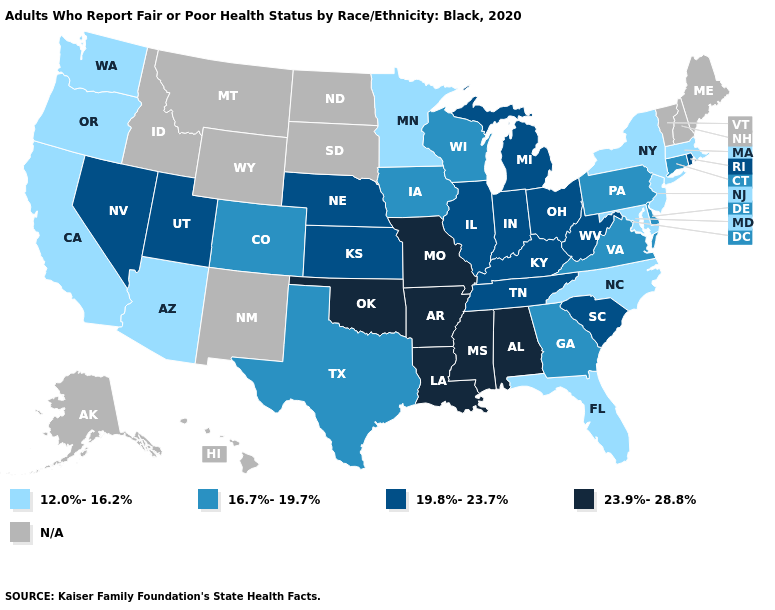Name the states that have a value in the range N/A?
Be succinct. Alaska, Hawaii, Idaho, Maine, Montana, New Hampshire, New Mexico, North Dakota, South Dakota, Vermont, Wyoming. What is the value of Texas?
Concise answer only. 16.7%-19.7%. Does Ohio have the highest value in the USA?
Give a very brief answer. No. Does Minnesota have the lowest value in the USA?
Quick response, please. Yes. Does Missouri have the highest value in the MidWest?
Give a very brief answer. Yes. What is the value of Utah?
Write a very short answer. 19.8%-23.7%. What is the value of Georgia?
Concise answer only. 16.7%-19.7%. Which states have the lowest value in the USA?
Quick response, please. Arizona, California, Florida, Maryland, Massachusetts, Minnesota, New Jersey, New York, North Carolina, Oregon, Washington. Among the states that border Ohio , does Pennsylvania have the highest value?
Answer briefly. No. Among the states that border Kentucky , which have the lowest value?
Concise answer only. Virginia. What is the value of North Carolina?
Short answer required. 12.0%-16.2%. What is the value of South Carolina?
Quick response, please. 19.8%-23.7%. Name the states that have a value in the range 16.7%-19.7%?
Keep it brief. Colorado, Connecticut, Delaware, Georgia, Iowa, Pennsylvania, Texas, Virginia, Wisconsin. Does Pennsylvania have the lowest value in the USA?
Keep it brief. No. Name the states that have a value in the range N/A?
Be succinct. Alaska, Hawaii, Idaho, Maine, Montana, New Hampshire, New Mexico, North Dakota, South Dakota, Vermont, Wyoming. 